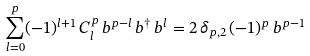Convert formula to latex. <formula><loc_0><loc_0><loc_500><loc_500>\sum _ { l = 0 } ^ { p } ( - 1 ) ^ { l + 1 } \, C _ { l } ^ { p } \, b ^ { p - l } \, b ^ { \dag } \, b ^ { l } = 2 \, \delta _ { p , 2 } \, ( - 1 ) ^ { p } \, b ^ { p - 1 }</formula> 